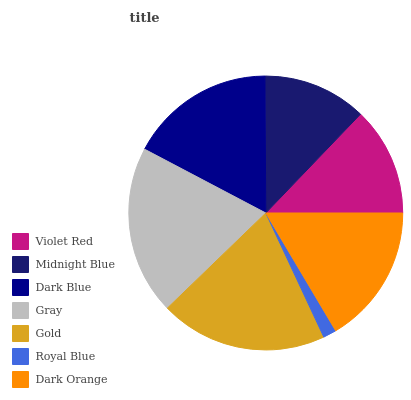Is Royal Blue the minimum?
Answer yes or no. Yes. Is Gray the maximum?
Answer yes or no. Yes. Is Midnight Blue the minimum?
Answer yes or no. No. Is Midnight Blue the maximum?
Answer yes or no. No. Is Violet Red greater than Midnight Blue?
Answer yes or no. Yes. Is Midnight Blue less than Violet Red?
Answer yes or no. Yes. Is Midnight Blue greater than Violet Red?
Answer yes or no. No. Is Violet Red less than Midnight Blue?
Answer yes or no. No. Is Dark Orange the high median?
Answer yes or no. Yes. Is Dark Orange the low median?
Answer yes or no. Yes. Is Dark Blue the high median?
Answer yes or no. No. Is Dark Blue the low median?
Answer yes or no. No. 